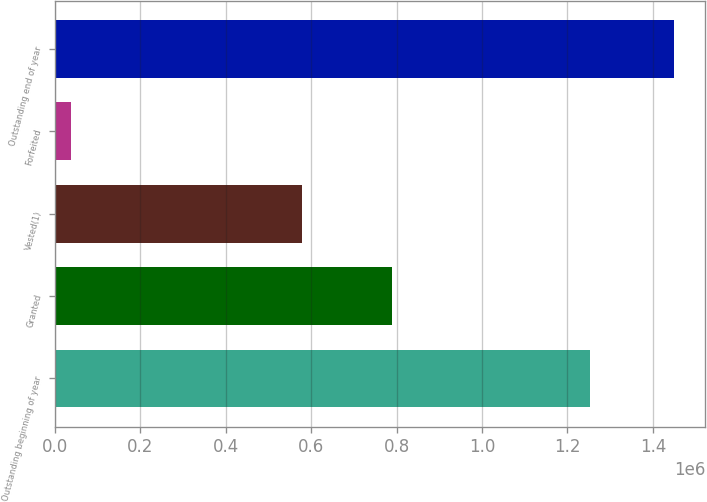<chart> <loc_0><loc_0><loc_500><loc_500><bar_chart><fcel>Outstanding beginning of year<fcel>Granted<fcel>Vested(1)<fcel>Forfeited<fcel>Outstanding end of year<nl><fcel>1.25245e+06<fcel>788677<fcel>579510<fcel>37909<fcel>1.45003e+06<nl></chart> 